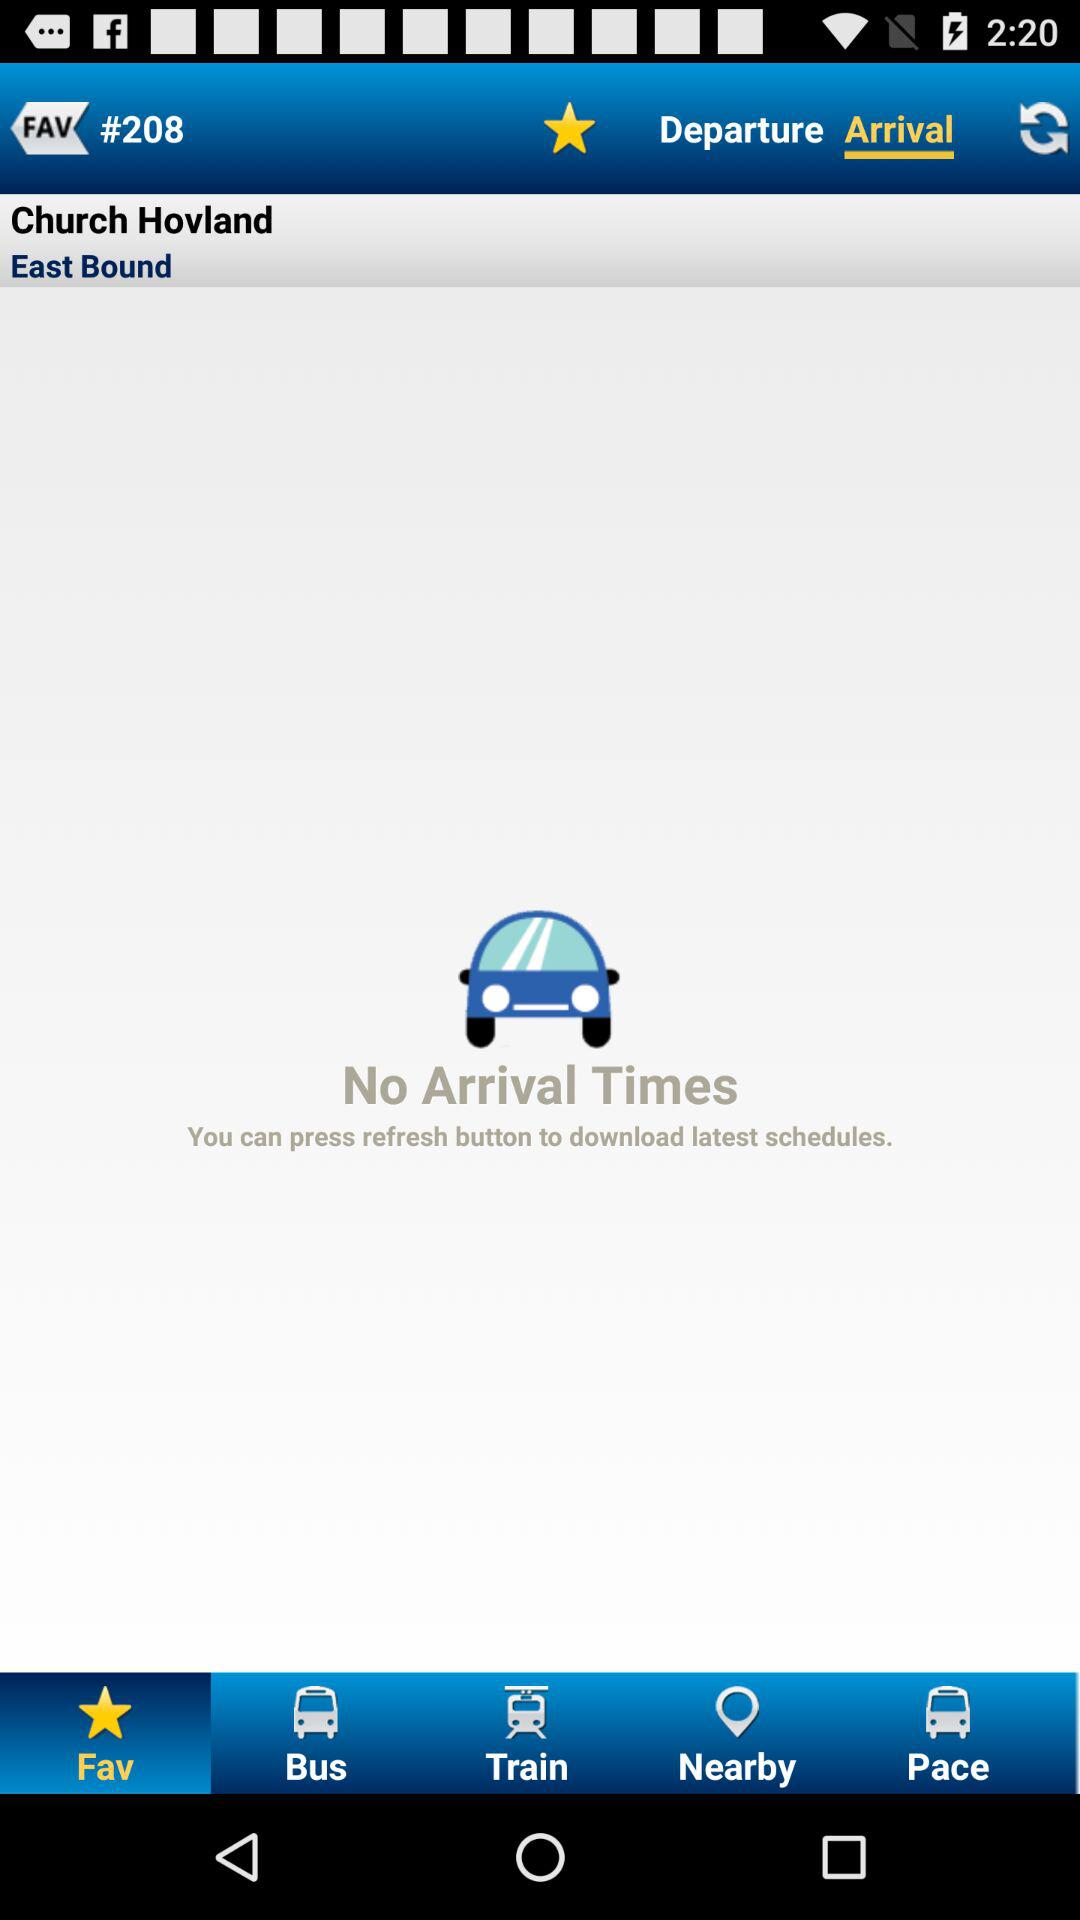Which tab is currently selected? The tabs "Arrival" and "Fav" are currently selected. 